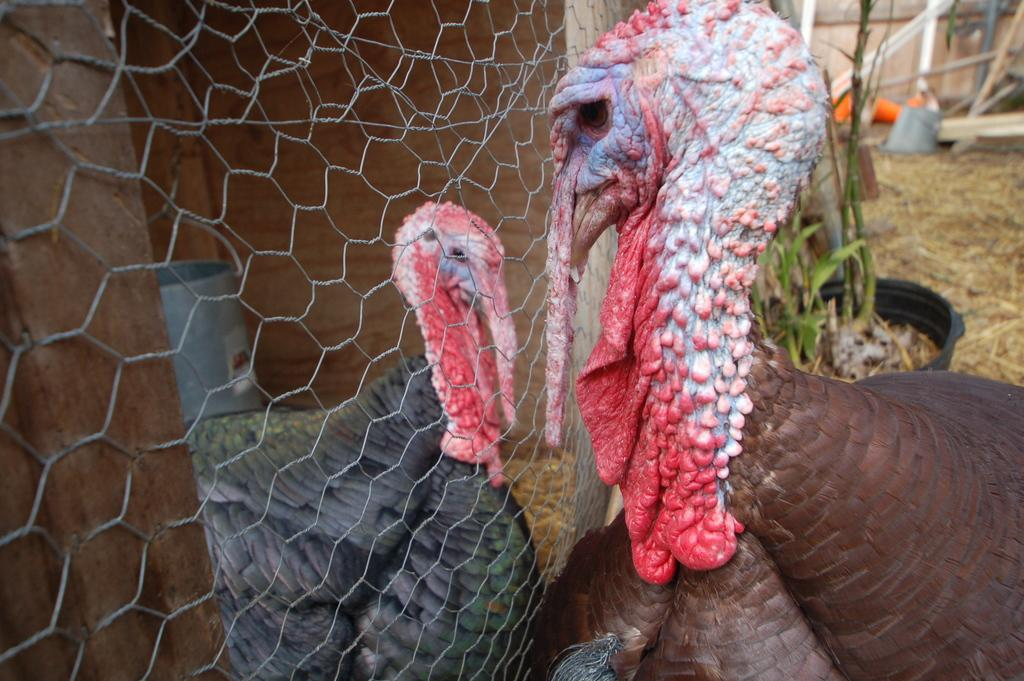What type of animals are in the image? There are turkey birds in the image. What can be seen separating the turkey birds from the background? There is a fence in the image. What type of structures are present in the image? There are wooden poles in the image. What type of vegetation can be seen in the background of the image? There is a plant in a pot in the background of the image. What is visible but not clearly identifiable in the background of the image? There are blurred objects in the background of the image. What type of jail can be seen in the image? There is no jail present in the image; it features turkey birds, a fence, wooden poles, a plant in a pot, and blurred objects in the background. 